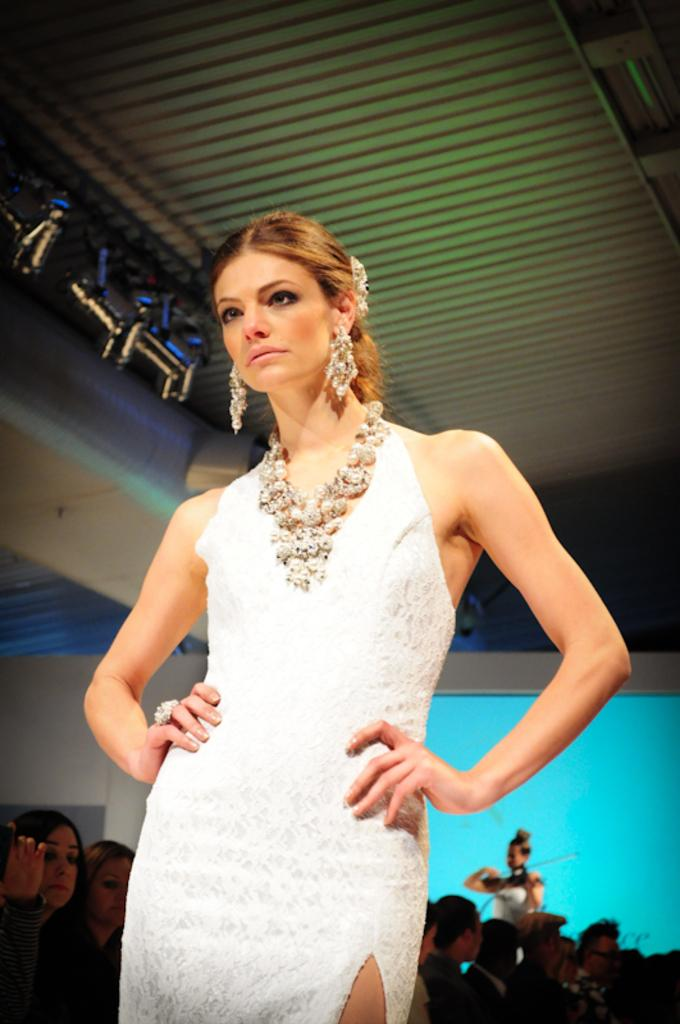Who is the main subject in the image? There is a woman in the image. What is the woman wearing? The woman is wearing a white dress, a necklace, and earrings. What is happening in the background of the image? There are other people in the background, and a person is playing a violin. What is the color of the background? The background of the image is blue. Can you see any feathers on the woman's dress in the image? There are no feathers visible on the woman's dress in the image. How many beans are present on the table in the image? There is no table or beans present in the image. 